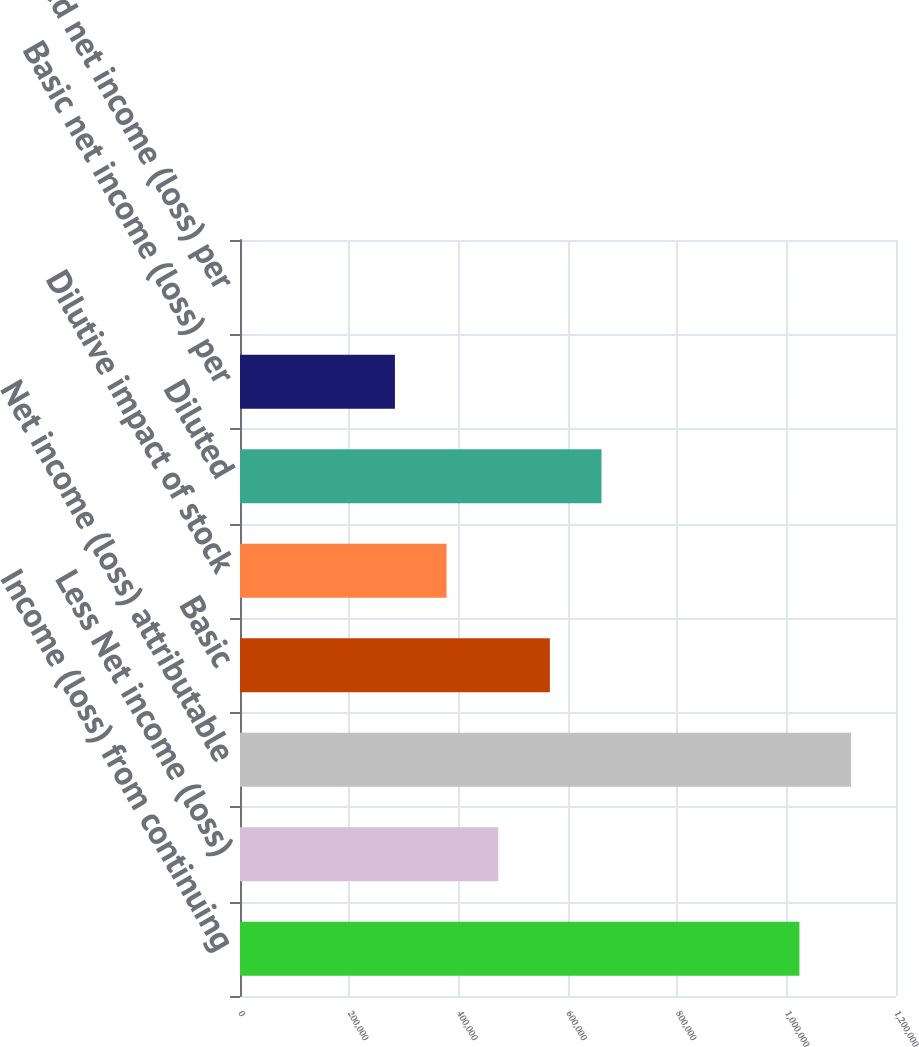Convert chart to OTSL. <chart><loc_0><loc_0><loc_500><loc_500><bar_chart><fcel>Income (loss) from continuing<fcel>Less Net income (loss)<fcel>Net income (loss) attributable<fcel>Basic<fcel>Dilutive impact of stock<fcel>Diluted<fcel>Basic net income (loss) per<fcel>Diluted net income (loss) per<nl><fcel>1.02337e+06<fcel>472348<fcel>1.11784e+06<fcel>566817<fcel>377878<fcel>661286<fcel>283409<fcel>2.04<nl></chart> 